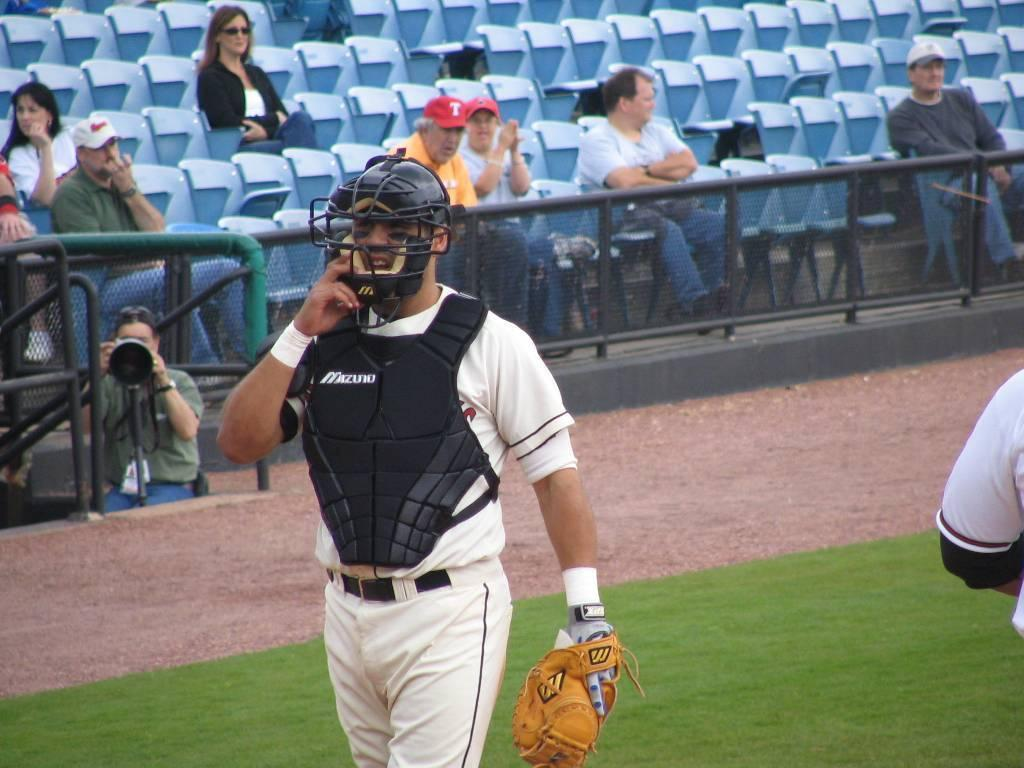Provide a one-sentence caption for the provided image. A baseball catcher wears a protective vest, the vest reads Mizuno. 